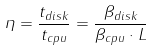<formula> <loc_0><loc_0><loc_500><loc_500>\eta = \frac { t _ { d i s k } } { t _ { c p u } } = \frac { \beta _ { d i s k } } { \beta _ { c p u } \cdot L }</formula> 